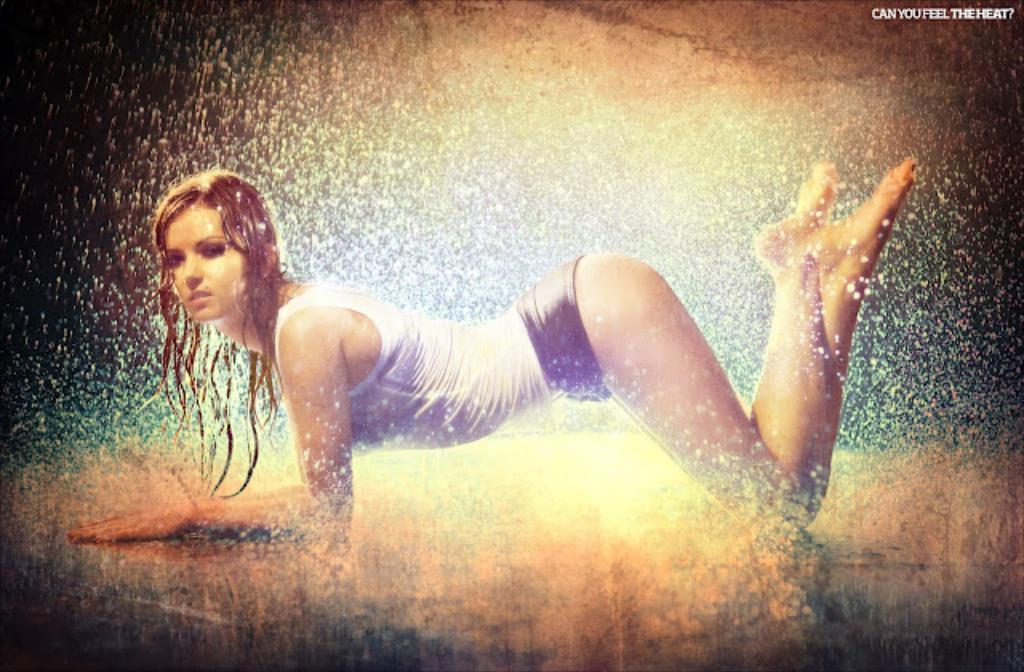Who is present in the image? There is a woman in the image. What is the woman's position in the image? The woman is on the floor. What can be seen in the background or surrounding the woman? There is water visible in the image. What type of button is the woman wearing on her shirt in the image? There is no button visible on the woman's shirt in the image. What kind of bottle is the woman holding in the image? There is no bottle present in the image. 